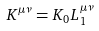<formula> <loc_0><loc_0><loc_500><loc_500>K ^ { \mu \nu } = K _ { 0 } L _ { 1 } ^ { \mu \nu }</formula> 